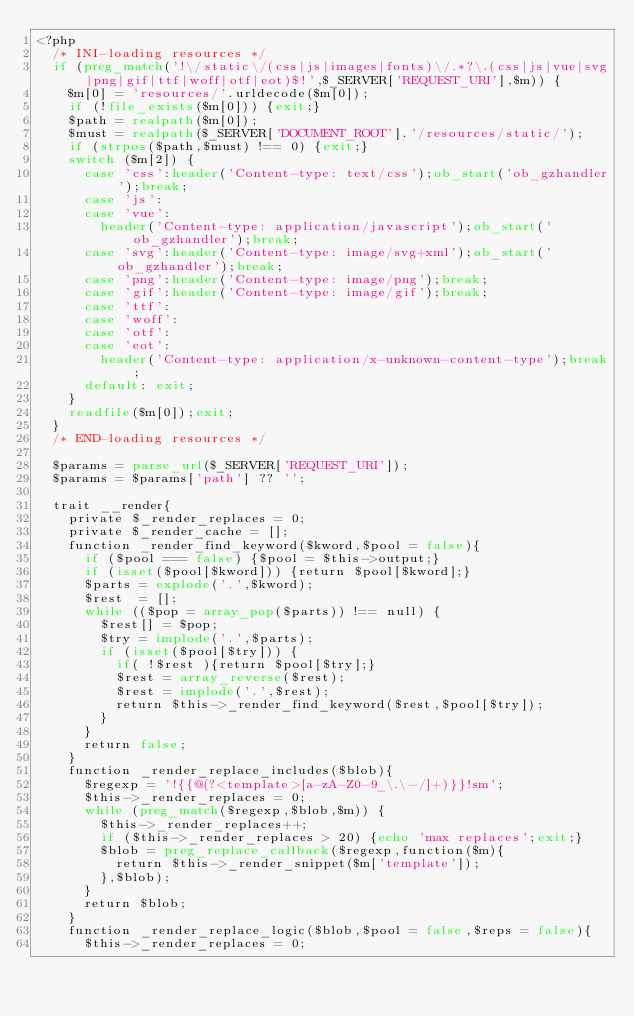Convert code to text. <code><loc_0><loc_0><loc_500><loc_500><_PHP_><?php
	/* INI-loading resources */
	if (preg_match('!\/static\/(css|js|images|fonts)\/.*?\.(css|js|vue|svg|png|gif|ttf|woff|otf|eot)$!',$_SERVER['REQUEST_URI'],$m)) {
		$m[0] = 'resources/'.urldecode($m[0]);
		if (!file_exists($m[0])) {exit;}
		$path = realpath($m[0]);
		$must = realpath($_SERVER['DOCUMENT_ROOT'].'/resources/static/');
		if (strpos($path,$must) !== 0) {exit;}
		switch ($m[2]) {
			case 'css':header('Content-type: text/css');ob_start('ob_gzhandler');break;
			case 'js':
			case 'vue':
				header('Content-type: application/javascript');ob_start('ob_gzhandler');break;
			case 'svg':header('Content-type: image/svg+xml');ob_start('ob_gzhandler');break;
			case 'png':header('Content-type: image/png');break;
			case 'gif':header('Content-type: image/gif');break;
			case 'ttf':
			case 'woff':
			case 'otf':
			case 'eot':
				header('Content-type: application/x-unknown-content-type');break;
			default: exit;
		}
		readfile($m[0]);exit;
	}
	/* END-loading resources */

	$params = parse_url($_SERVER['REQUEST_URI']);
	$params = $params['path'] ?? '';

	trait __render{
		private $_render_replaces = 0;
		private $_render_cache = [];
		function _render_find_keyword($kword,$pool = false){
			if ($pool === false) {$pool = $this->output;}
			if (isset($pool[$kword])) {return $pool[$kword];}
			$parts = explode('.',$kword);
			$rest  = [];
			while (($pop = array_pop($parts)) !== null) {
				$rest[] = $pop;
				$try = implode('.',$parts);
				if (isset($pool[$try])) {
					if( !$rest ){return $pool[$try];}
					$rest = array_reverse($rest);
					$rest = implode('.',$rest);
					return $this->_render_find_keyword($rest,$pool[$try]);
				}
			}
			return false;
		}
		function _render_replace_includes($blob){
			$regexp = '!{{@(?<template>[a-zA-Z0-9_\.\-/]+)}}!sm';
			$this->_render_replaces = 0;
			while (preg_match($regexp,$blob,$m)) {
				$this->_render_replaces++;
				if ($this->_render_replaces > 20) {echo 'max replaces';exit;}
				$blob = preg_replace_callback($regexp,function($m){
					return $this->_render_snippet($m['template']);
				},$blob);
			}
			return $blob;
		}
		function _render_replace_logic($blob,$pool = false,$reps = false){
			$this->_render_replaces = 0;</code> 